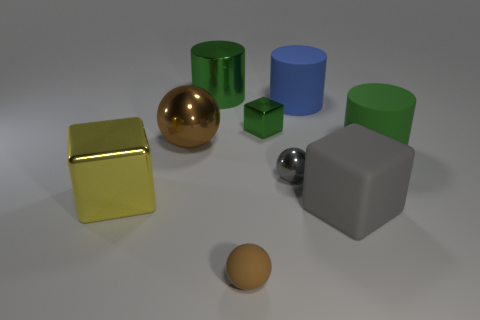Add 1 small green things. How many objects exist? 10 Subtract all cubes. How many objects are left? 6 Add 7 green rubber objects. How many green rubber objects are left? 8 Add 9 small brown matte spheres. How many small brown matte spheres exist? 10 Subtract 1 gray balls. How many objects are left? 8 Subtract all big blue matte cylinders. Subtract all tiny gray spheres. How many objects are left? 7 